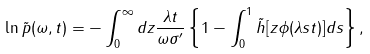<formula> <loc_0><loc_0><loc_500><loc_500>\ln \tilde { p } ( \omega , t ) = - \int _ { 0 } ^ { \infty } d z \frac { \lambda t } { \omega \sigma ^ { \prime } } \left \{ 1 - \int _ { 0 } ^ { 1 } \tilde { h } [ z \phi ( \lambda s t ) ] d s \right \} ,</formula> 